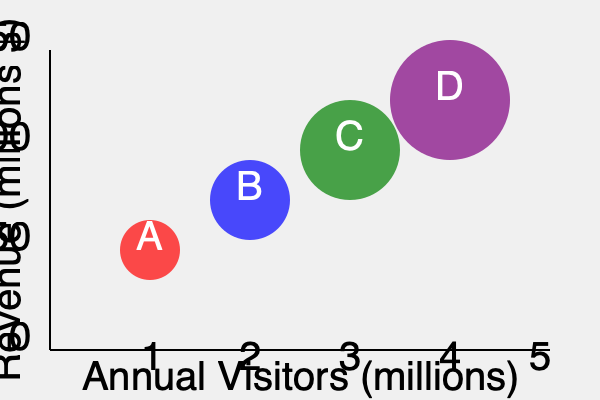Analyze the bubble chart representing four museums (A, B, C, and D) and their financial performance. Which museum demonstrates the most efficient revenue generation relative to its visitor numbers, and what financial metric does this suggest? To answer this question, we need to analyze the relationship between visitor numbers, revenue, and the size of each bubble for the four museums:

1. Interpret the axes:
   - X-axis: Annual Visitors (millions)
   - Y-axis: Revenue (millions $)

2. Understand bubble size:
   The size of each bubble likely represents a third variable, such as total assets or operating costs.

3. Analyze each museum:
   A (Red): Lowest visitors and revenue, smallest bubble
   B (Blue): Second-lowest visitors and revenue, second-smallest bubble
   C (Green): Second-highest visitors and revenue, second-largest bubble
   D (Purple): Highest visitors and revenue, largest bubble

4. Calculate revenue per visitor:
   This metric indicates efficiency in generating revenue from visitors.
   
   Revenue per visitor = Revenue / Annual Visitors
   
   A: $\frac{50}{1} = 50$ $/visitor
   B: $\frac{100}{2} = 50$ $/visitor
   C: $\frac{125}{3} \approx 41.67$ $/visitor
   D: $\frac{150}{4} = 37.5$ $/visitor

5. Interpret results:
   Museums A and B have the highest revenue per visitor at $50/visitor.

6. Consider other factors:
   Given that A has a smaller bubble (potentially indicating lower operating costs or total assets), it may be more efficient overall.

The most efficient revenue generation relative to visitor numbers is demonstrated by Museum A. This suggests a high profit margin per visitor, indicating effective monetization strategies such as premium experiences, high-value merchandise, or efficient cost management.
Answer: Museum A; high profit margin per visitor 